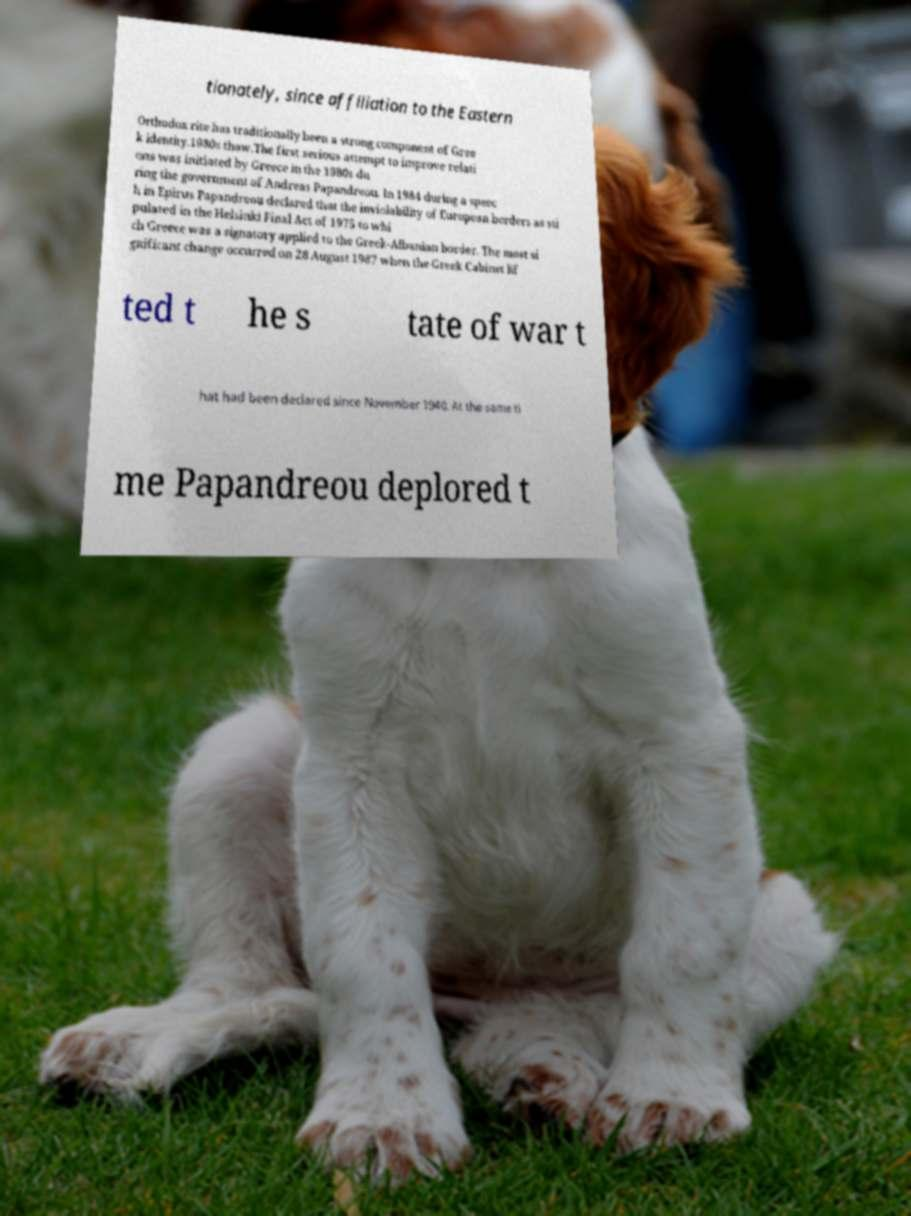What messages or text are displayed in this image? I need them in a readable, typed format. tionately, since affiliation to the Eastern Orthodox rite has traditionally been a strong component of Gree k identity.1980s thaw.The first serious attempt to improve relati ons was initiated by Greece in the 1980s du ring the government of Andreas Papandreou. In 1984 during a speec h in Epirus Papandreou declared that the inviolability of European borders as sti pulated in the Helsinki Final Act of 1975 to whi ch Greece was a signatory applied to the Greek-Albanian border. The most si gnificant change occurred on 28 August 1987 when the Greek Cabinet lif ted t he s tate of war t hat had been declared since November 1940. At the same ti me Papandreou deplored t 